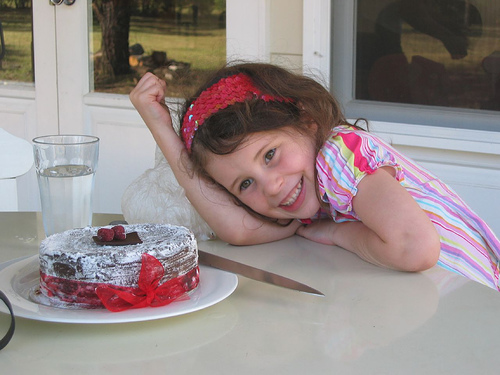<image>What is the design on the plate? I am not sure the design on the plate. However, it can be seen as 'plain', 'stripe', 'circle' or 'solid'. What is the design on the plate? I am not sure what is the design on the plate. It can be seen as plain, stripe, circle or solid. 